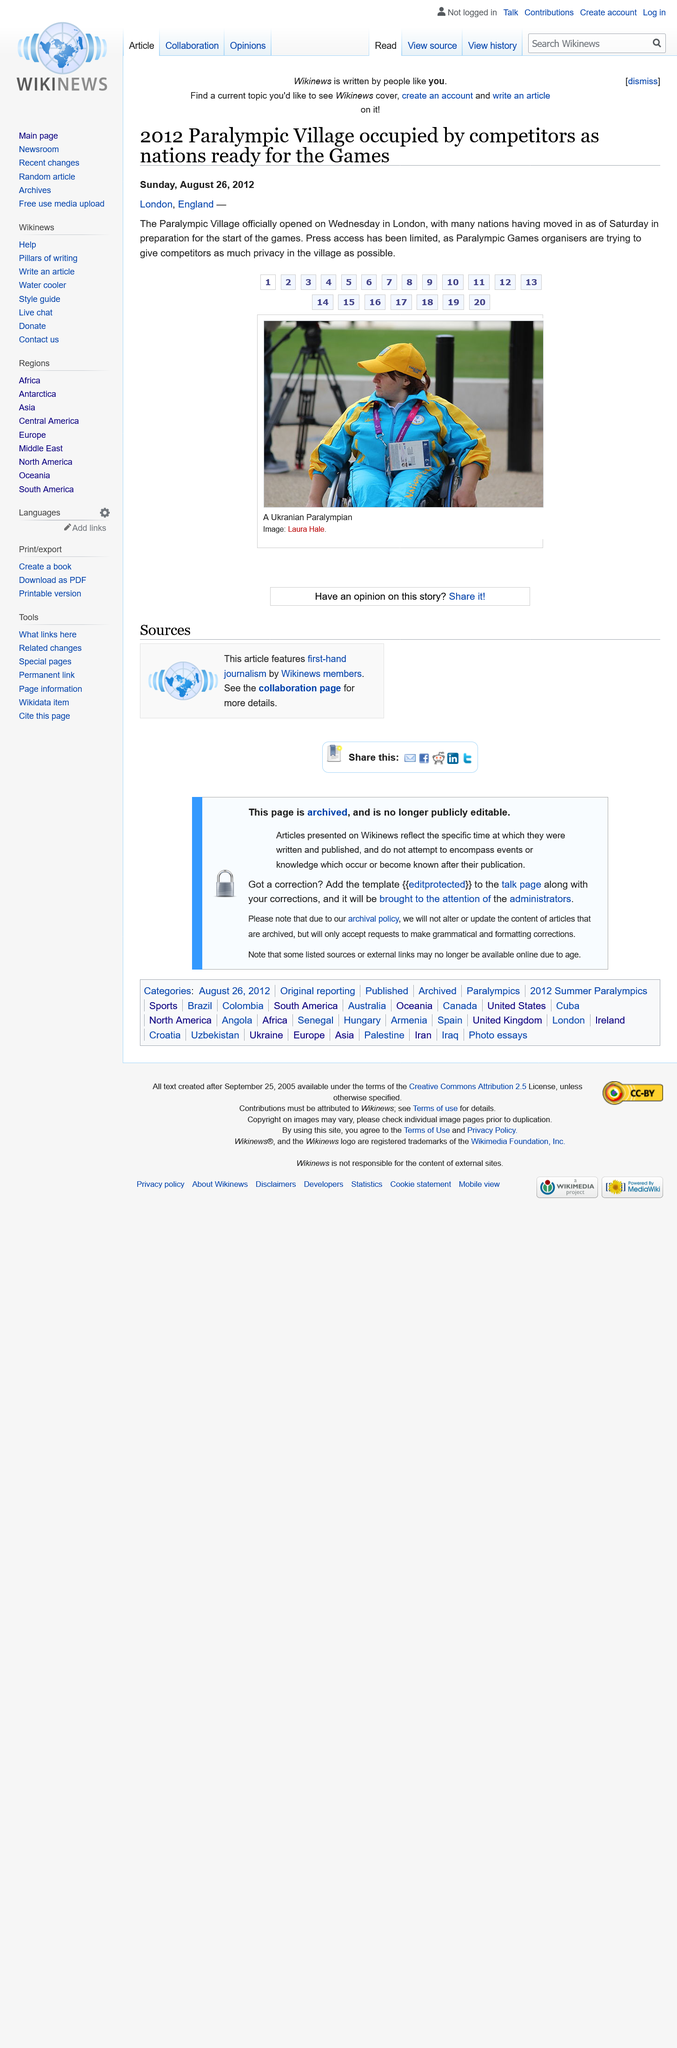List a handful of essential elements in this visual. On Sunday, August 26th, 2012, the article was written. The access of the person has been restricted in order to provide the privacy of the competitors to the maximum extent possible in the village. The image in this article features Ukranian Paralympian. 